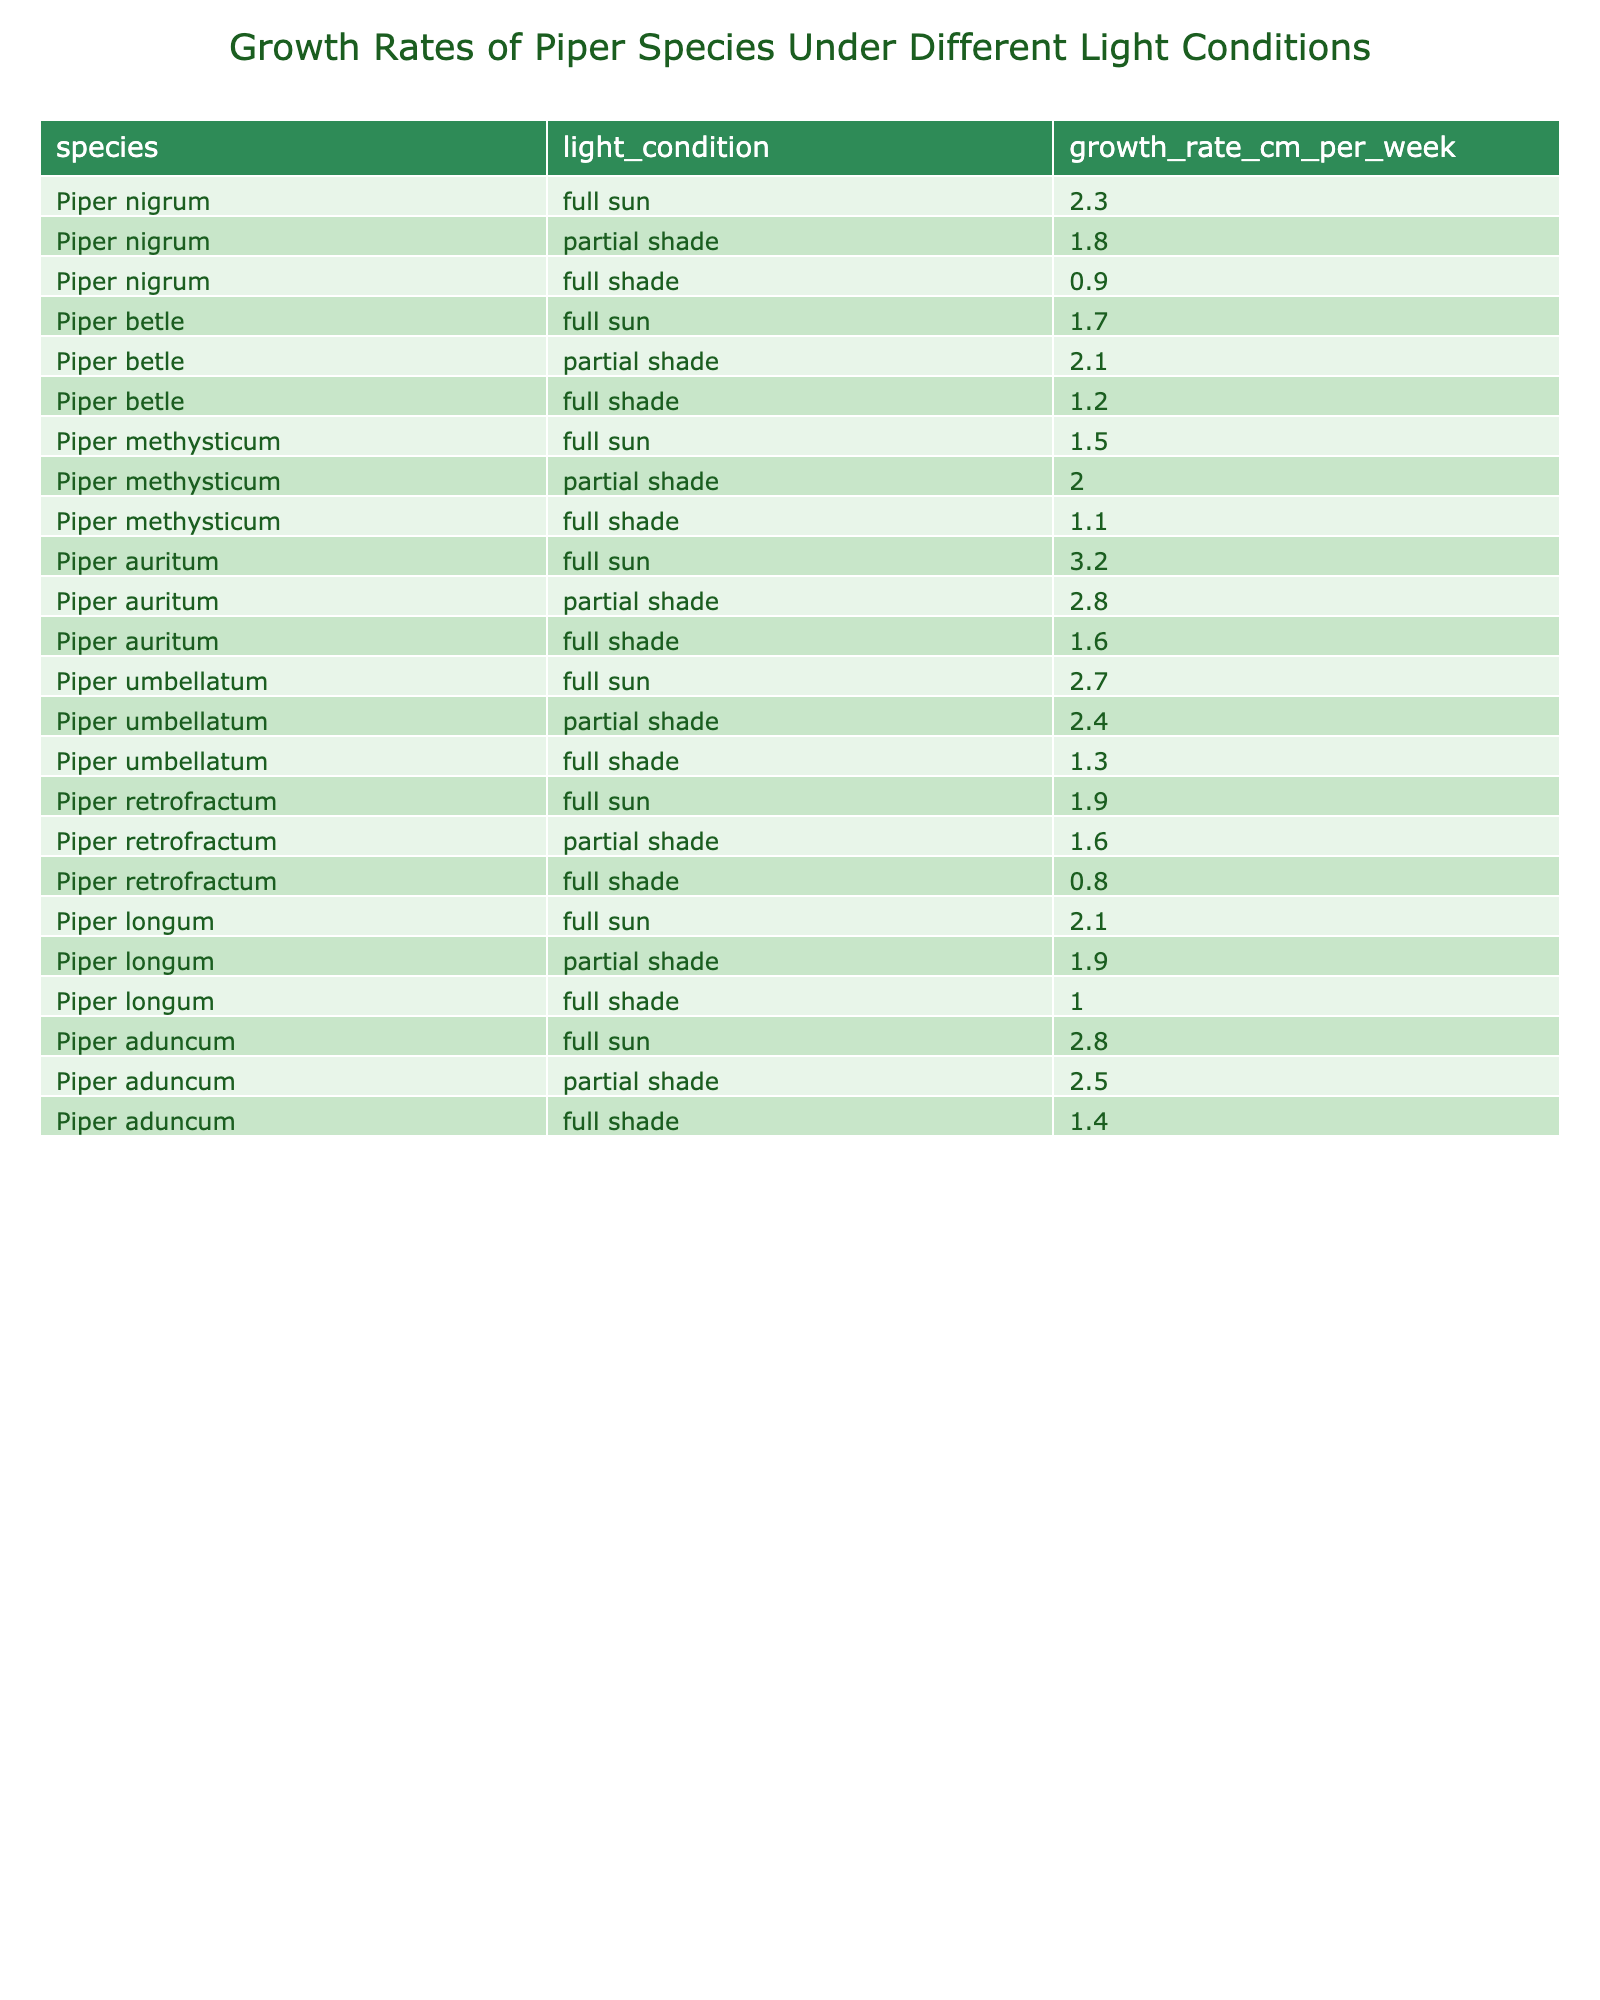What is the growth rate of Piper nigrum under full sun? Looking at the table, the growth rate of Piper nigrum under full sun is directly listed as 2.3 cm per week.
Answer: 2.3 cm per week Which Piper species grows the fastest in full sun conditions? The table shows the growth rates in full sun for each species. Piper auritum has the highest growth rate at 3.2 cm per week.
Answer: Piper auritum What is the average growth rate of Piper betle under partial shade? The table indicates the growth rate of Piper betle in partial shade is 2.1 cm per week. Since there's only one entry for this condition, the average is also 2.1 cm per week.
Answer: 2.1 cm per week How does the growth rate of Piper methysticum compare between full sun and full shade? In full sun, Piper methysticum has a growth rate of 1.5 cm per week, whereas in full shade it is 1.1 cm per week. The difference in growth rates is 1.5 - 1.1 = 0.4 cm per week.
Answer: 0.4 cm per week Is there a species that exhibits higher growth rates in partial shade compared to full sun? Comparing the growth rates in the table, Piper betle and Piper aduncum both have higher growth rates in partial shade (2.1 cm and 2.5 cm respectively) than in full sun (1.7 cm and 2.8 cm).
Answer: Yes Which light condition results in the highest average growth rate across all Piper species? To find the highest average growth rate, we must calculate the average for each light condition. Full sun averages to 2.1 cm (sum: 2.3+1.7+1.5+3.2+2.7+1.9+2.1+2.8) = 1.925 cm per condition, partial shade averages 2.0 cm (sum: 1.8+2.1+2.0+2.8+2.4+1.6+1.9+2.5) = 1.65, while full shade averages to 1.3 cm. Therefore, the highest average is from full sun at 2.1 cm per week.
Answer: Full sun What is the difference in growth rates of Piper aduncum between full sun and full shade? The growth rate of Piper aduncum in full sun is 2.8 cm and in full shade it is 1.4 cm. Therefore, the difference can be calculated as 2.8 - 1.4 = 1.4 cm per week.
Answer: 1.4 cm per week Do any Piper species have the same growth rates under full shade? From the table, Piper retrofractum and Piper methysticum both show a growth rate of 1.1 cm under full shade. Thus, they have the same growth rate.
Answer: Yes Which Piper species has the lowest growth rate in full shade? Evaluating the entries for full shade in the table, the lowest growth rate is found in Piper retrofractum at 0.8 cm per week.
Answer: Piper retrofractum What is the total growth rate for Piper umbellatum across all light conditions? The growth rates for Piper umbellatum in different light conditions are 2.7 cm (full sun), 2.4 cm (partial shade), and 1.3 cm (full shade). Adding these gives 2.7 + 2.4 + 1.3 = 6.4 cm per week.
Answer: 6.4 cm per week 